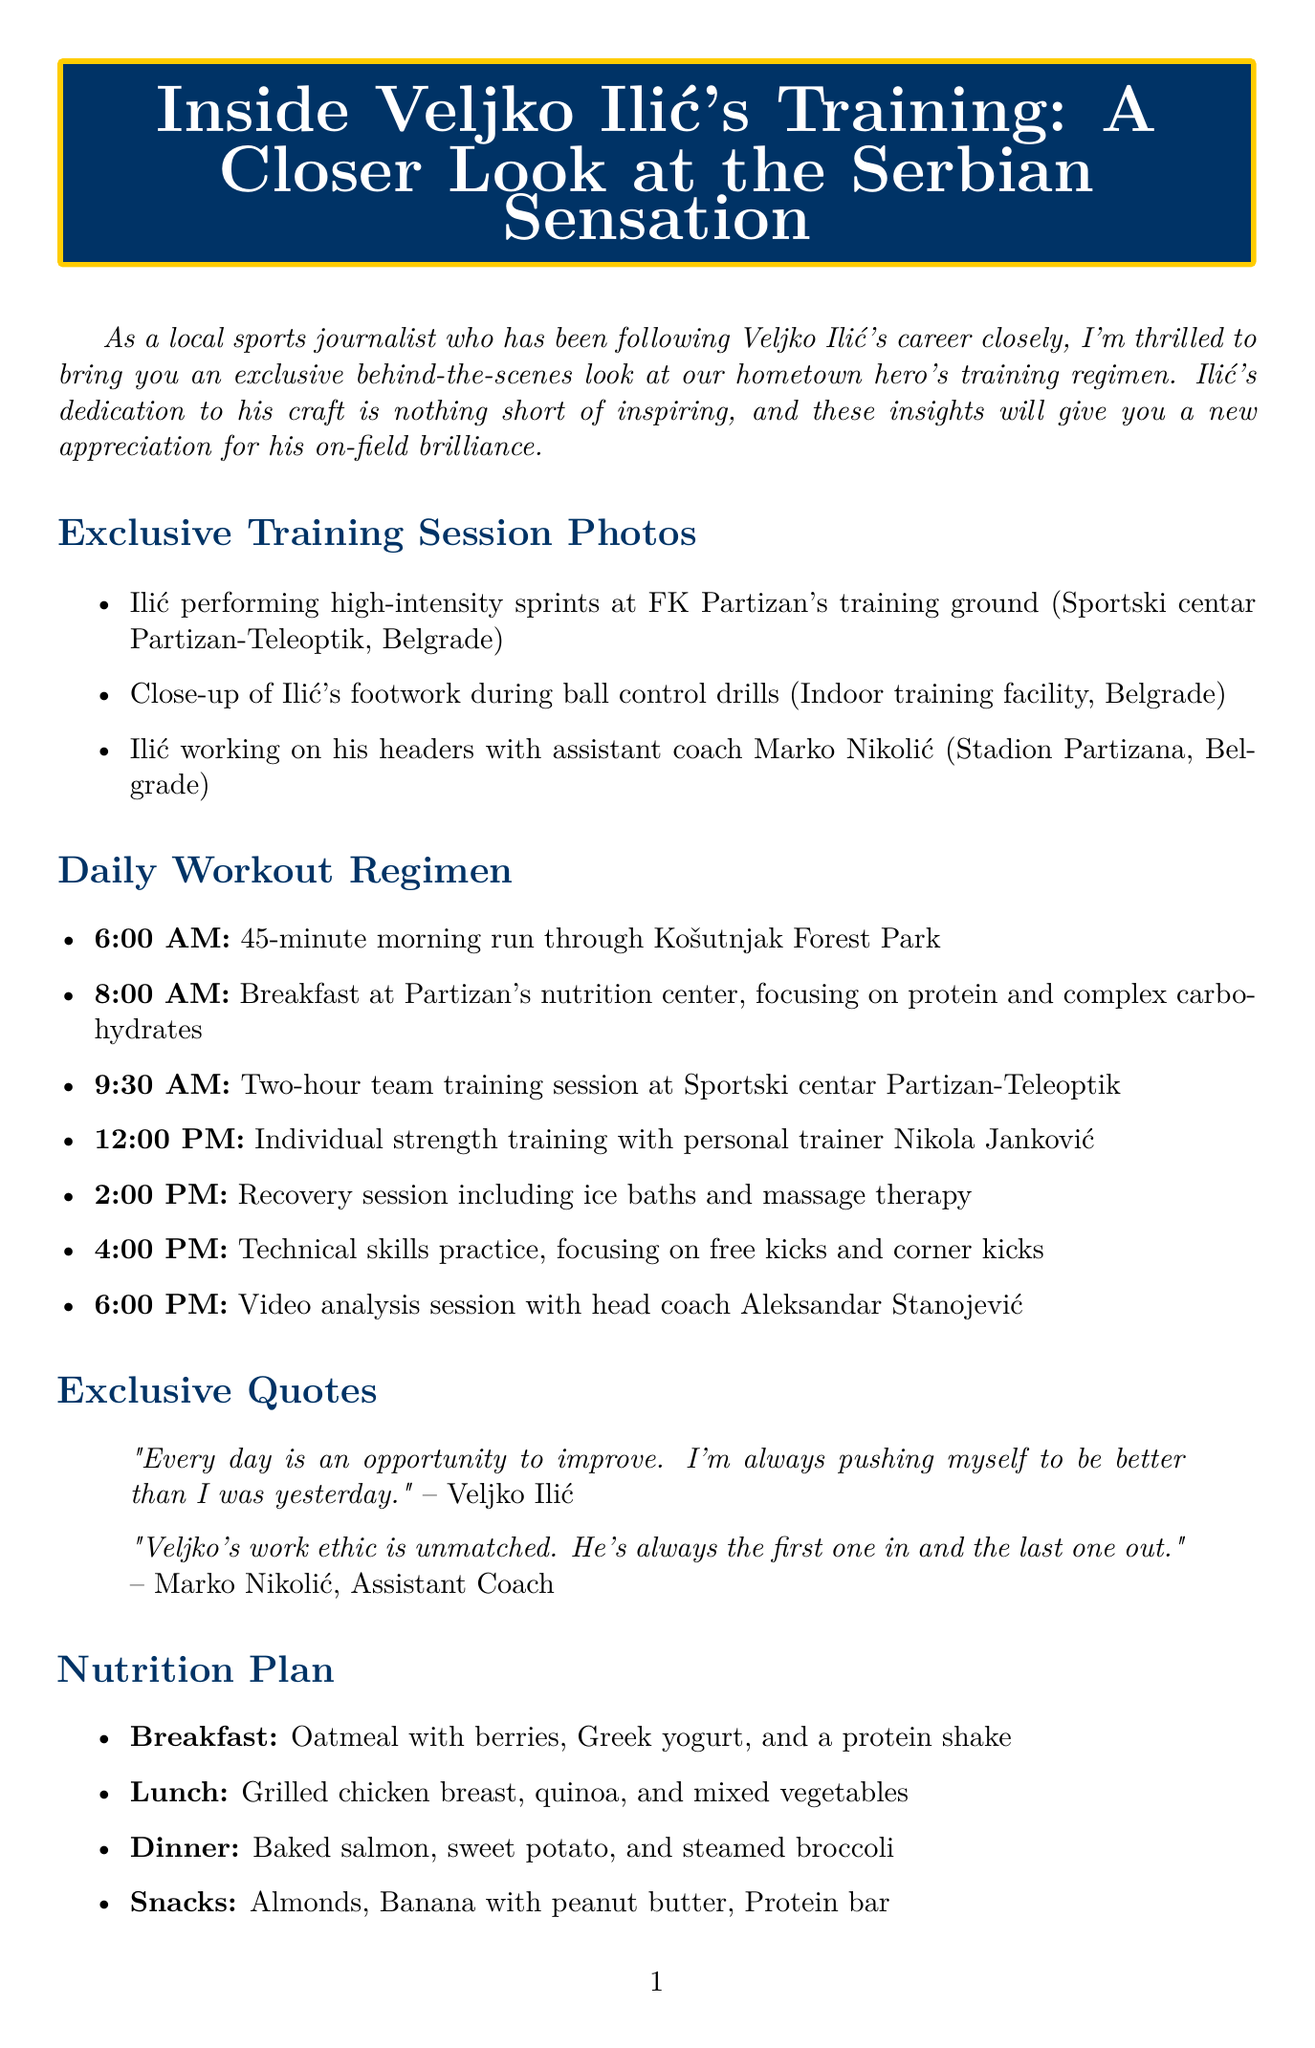What is the title of the newsletter? The title of the newsletter is mentioned at the top of the document.
Answer: Inside Veljko Ilić's Training: A Closer Look at the Serbian Sensation What time does Veljko Ilić start his morning run? The document lists the activities in the workout regimen, including the time for the morning run.
Answer: 6:00 AM Who is the photographer of the close-up footwork photo? The document attributes each photo to a specific photographer, including the footwork photo.
Answer: Ana Jovanović Which meal comprises grilled chicken breast? The nutrition plan specifies what is included in each meal, identifying the lunch components.
Answer: Lunch What is Veljko Ilić's quote about improvement? The document provides quotes directly attributed to Veljko Ilić.
Answer: "Every day is an opportunity to improve. I'm always pushing myself to be better than I was yesterday." How many upcoming fixtures are listed? The upcoming fixtures section outlines the matches that are scheduled, providing the total number.
Answer: 2 What is the location of the team training session? The document indicates the venue where the team training session takes place.
Answer: Sportski centar Partizan-Teleoptik What activity is happening at 4:00 PM? The workout regimen includes a specific activity for each designated time, including the one at 4:00 PM.
Answer: Technical skills practice Who is mentioned as the first one in and last one out? The quotes include a specific person sharing insights about Ilić's work ethic.
Answer: Marko Nikolić, Assistant Coach 